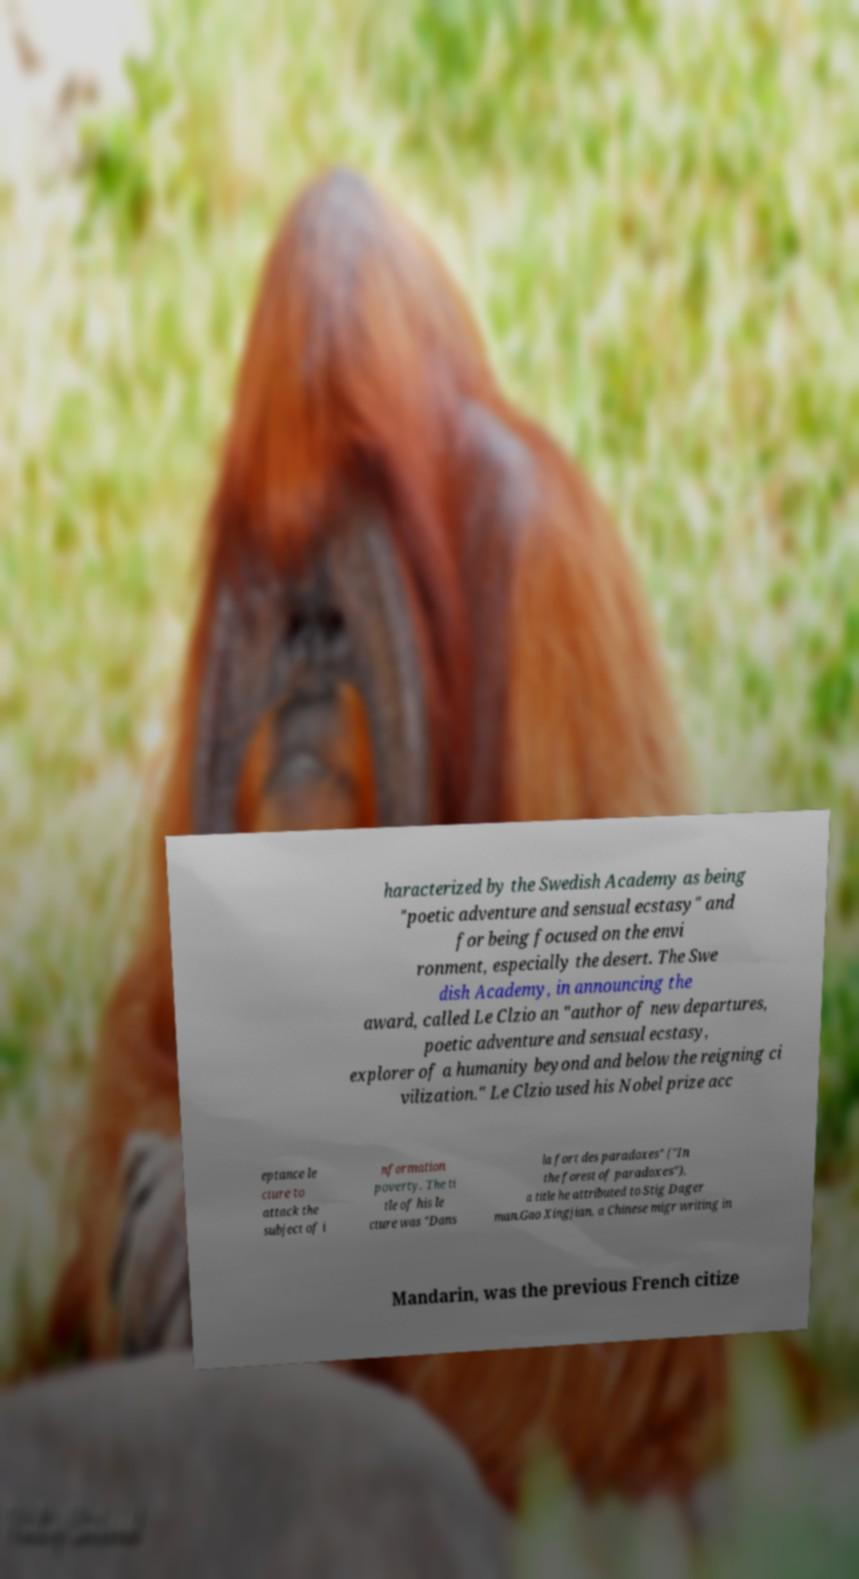Please read and relay the text visible in this image. What does it say? haracterized by the Swedish Academy as being "poetic adventure and sensual ecstasy" and for being focused on the envi ronment, especially the desert. The Swe dish Academy, in announcing the award, called Le Clzio an "author of new departures, poetic adventure and sensual ecstasy, explorer of a humanity beyond and below the reigning ci vilization." Le Clzio used his Nobel prize acc eptance le cture to attack the subject of i nformation poverty. The ti tle of his le cture was "Dans la fort des paradoxes" ("In the forest of paradoxes"), a title he attributed to Stig Dager man.Gao Xingjian, a Chinese migr writing in Mandarin, was the previous French citize 